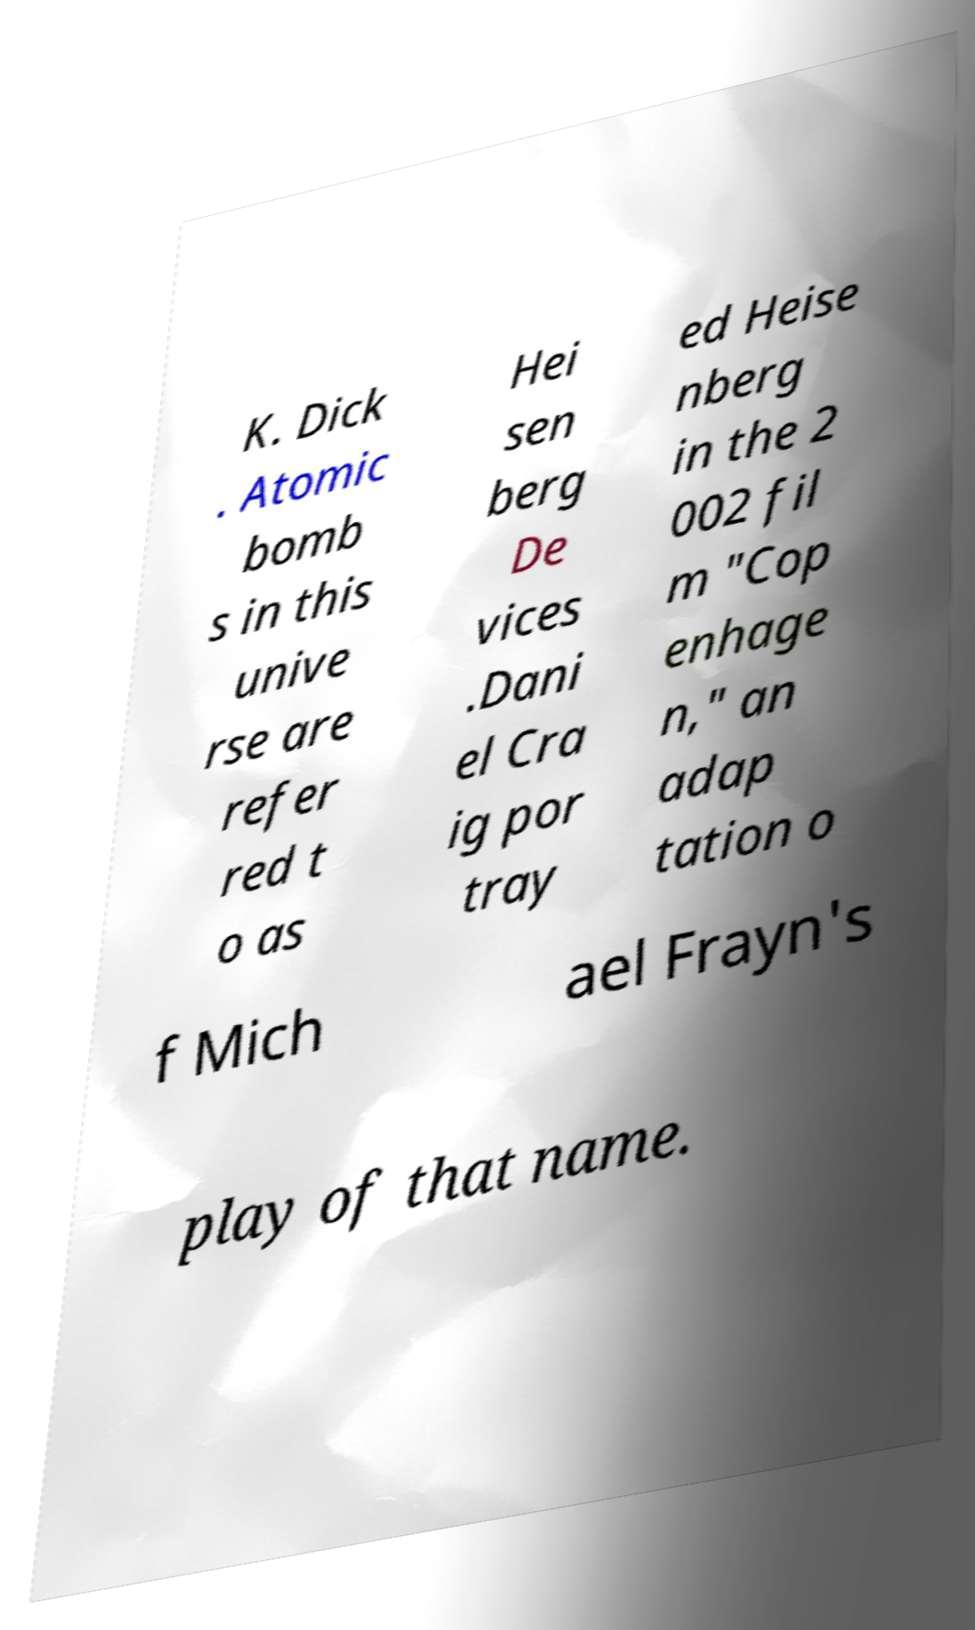What messages or text are displayed in this image? I need them in a readable, typed format. K. Dick . Atomic bomb s in this unive rse are refer red t o as Hei sen berg De vices .Dani el Cra ig por tray ed Heise nberg in the 2 002 fil m "Cop enhage n," an adap tation o f Mich ael Frayn's play of that name. 